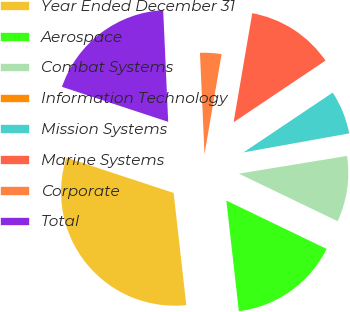Convert chart. <chart><loc_0><loc_0><loc_500><loc_500><pie_chart><fcel>Year Ended December 31<fcel>Aerospace<fcel>Combat Systems<fcel>Information Technology<fcel>Mission Systems<fcel>Marine Systems<fcel>Corporate<fcel>Total<nl><fcel>31.86%<fcel>16.06%<fcel>9.73%<fcel>0.25%<fcel>6.57%<fcel>12.9%<fcel>3.41%<fcel>19.22%<nl></chart> 